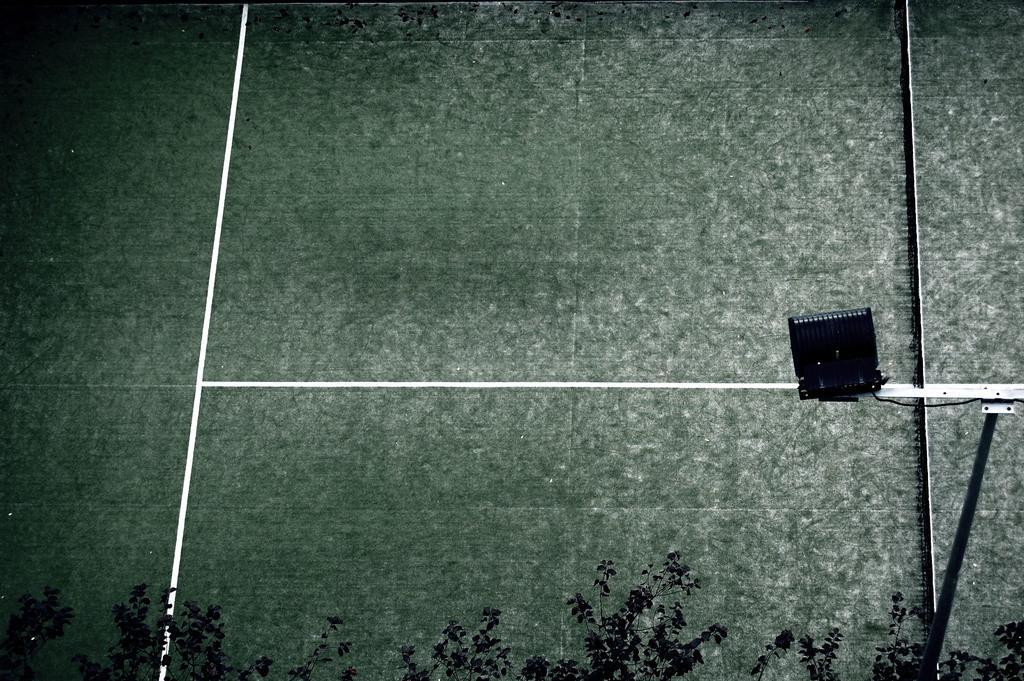Please provide a concise description of this image. In this image I can see the white and green color surface and trees. I can also see the black color object on the surface. 